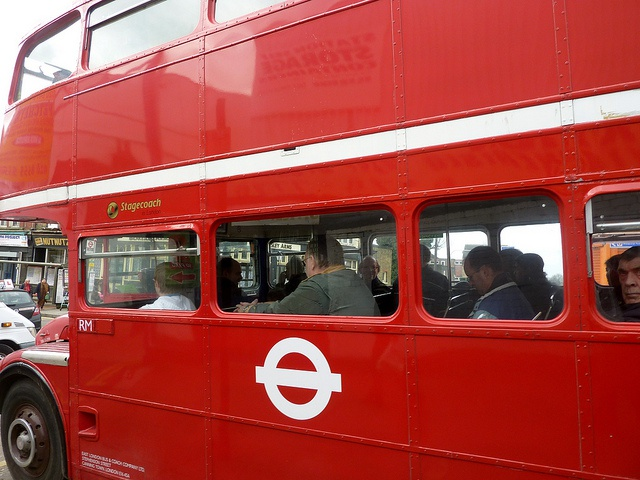Describe the objects in this image and their specific colors. I can see bus in brown, salmon, white, and black tones, people in white, gray, and black tones, people in white, black, and gray tones, people in white, black, lightgray, and gray tones, and people in white, black, and gray tones in this image. 